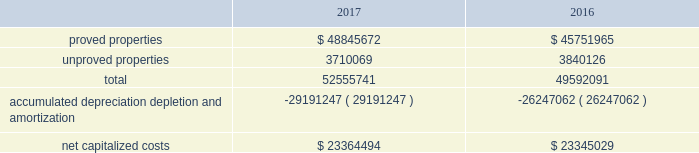Eog resources , inc .
Supplemental information to consolidated financial statements ( continued ) capitalized costs relating to oil and gas producing activities .
The table sets forth the capitalized costs relating to eog's crude oil and natural gas producing activities at december 31 , 2017 and 2016: .
Costs incurred in oil and gas property acquisition , exploration and development activities .
The acquisition , exploration and development costs disclosed in the following tables are in accordance with definitions in the extractive industries - oil and a gas topic of the accounting standards codification ( asc ) .
Acquisition costs include costs incurred to purchase , lease or otherwise acquire property .
Exploration costs include additions to exploratory wells , including those in progress , and exploration expenses .
Development costs include additions to production facilities and equipment and additions to development wells , including those in progress. .
What are the average cost of accumulated depreciation depletion and amortization for 2016 and 2017? 
Rationale: it is the sum of the accumulated depreciation depletion and amortization for both years divided by two .
Computations: table_average(accumulated depreciation depletion and amortization, none)
Answer: -27719154.5. 